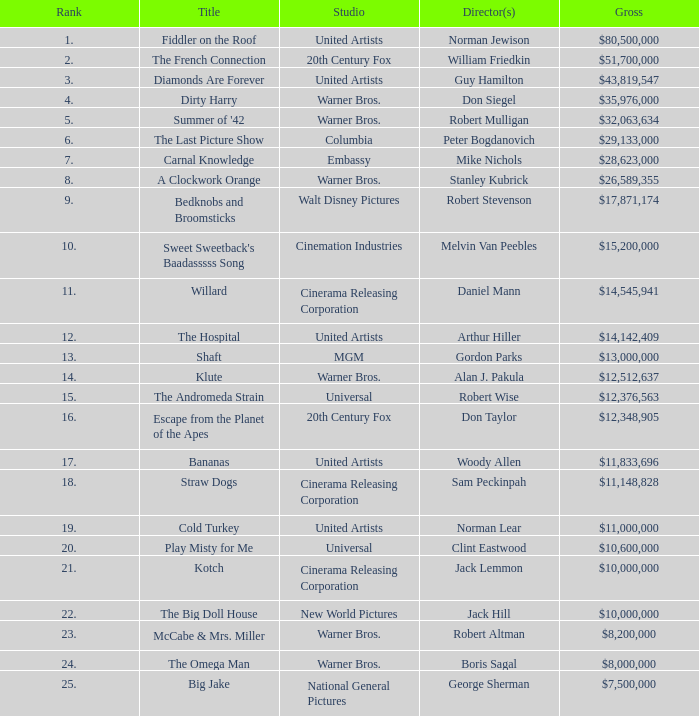What position does the title hold with a total revenue of $26,589,355? 8.0. 